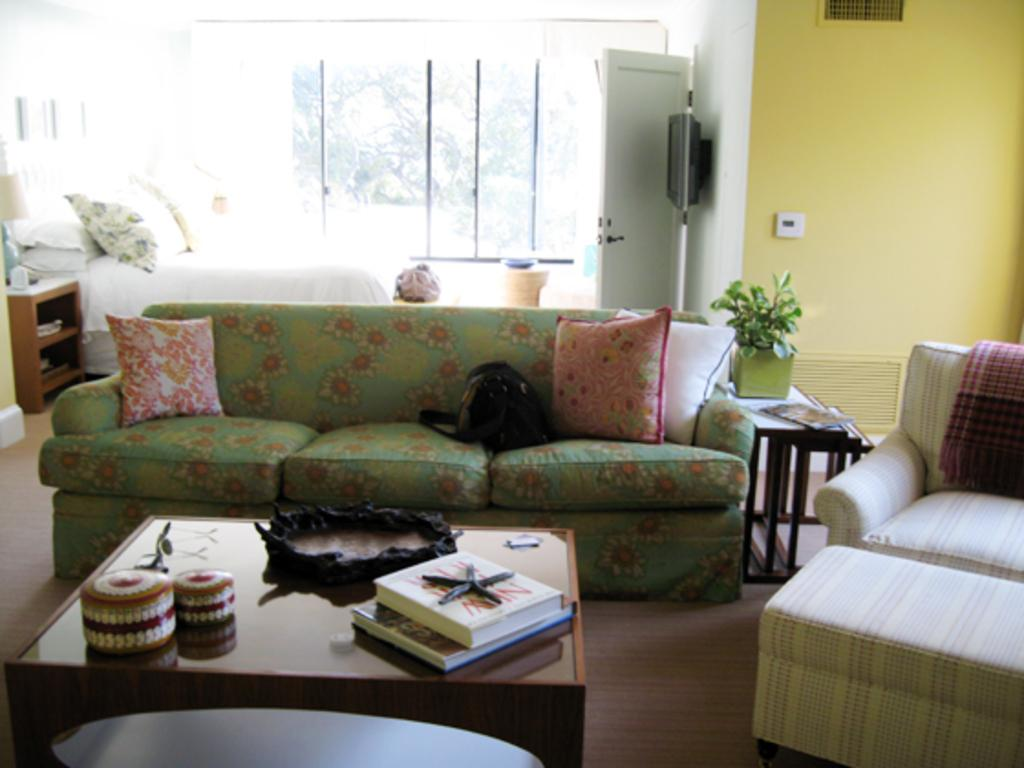What type of furniture is present in the image? There is a sofa in the image. What is placed on the sofa? There are pillows on the sofa. What architectural feature can be seen in the image? There is a door in the image. What type of sleeping arrangement is visible in the image? There is a bed in the image. What type of storage is present in the image? There is a shelf in the image. What allows natural light to enter the room in the image? There is a window in the image. What type of greenery is present in the image? There is a plant in the image. What type of surface is present for placing objects in the image? There is a table in the image. What type of reading material is present in the image? There are books in the image. What object is placed on the table in the image? There is an object on the table in the image. Can you describe the trail of fog that is visible in the image? There is no trail of fog present in the image. What type of marble is used for the flooring in the image? There is no marble present in the image; the flooring is not described. 